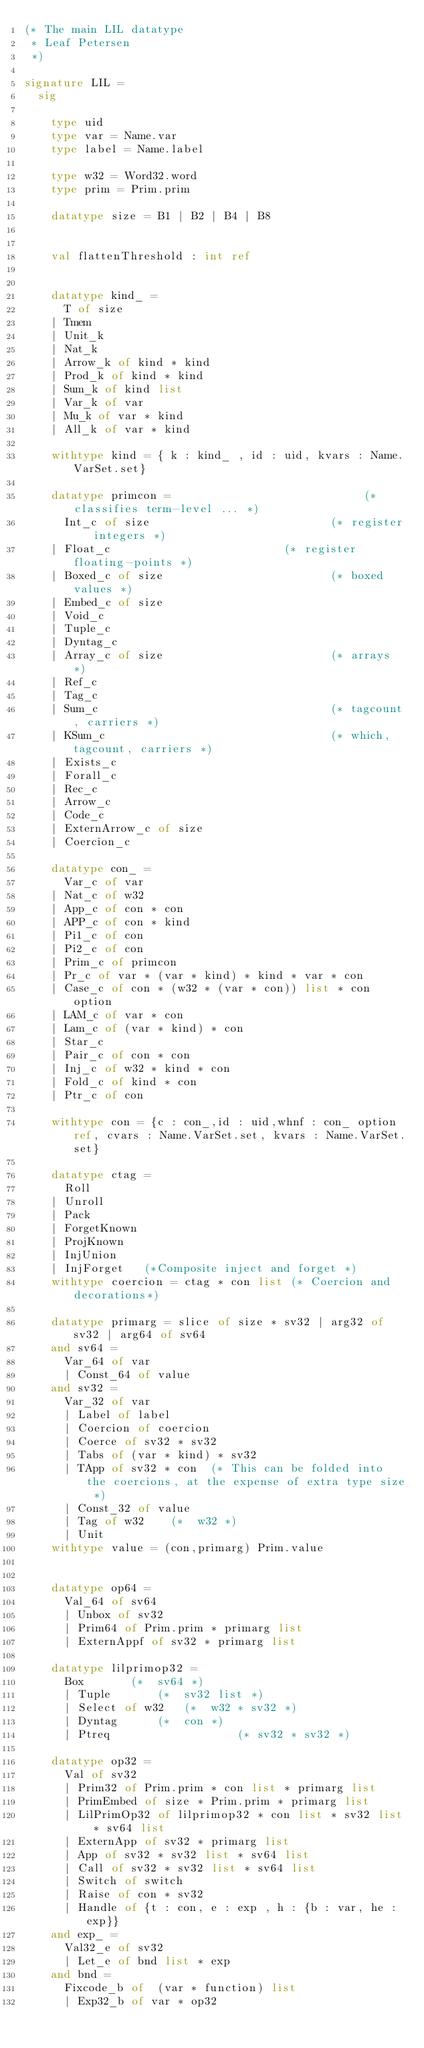Convert code to text. <code><loc_0><loc_0><loc_500><loc_500><_SML_>(* The main LIL datatype
 * Leaf Petersen
 *)

signature LIL =
  sig

    type uid    
    type var = Name.var
    type label = Name.label
      
    type w32 = Word32.word
    type prim = Prim.prim

    datatype size = B1 | B2 | B4 | B8


    val flattenThreshold : int ref


    datatype kind_ =
      T of size
    | Tmem
    | Unit_k
    | Nat_k
    | Arrow_k of kind * kind
    | Prod_k of kind * kind
    | Sum_k of kind list
    | Var_k of var
    | Mu_k of var * kind
    | All_k of var * kind

    withtype kind = { k : kind_ , id : uid, kvars : Name.VarSet.set}
      
    datatype primcon =                             (* classifies term-level ... *)
      Int_c of size                           (* register integers *)
    | Float_c                          (* register floating-points *)
    | Boxed_c of size                         (* boxed values *)
    | Embed_c of size
    | Void_c
    | Tuple_c
    | Dyntag_c
    | Array_c of size                         (* arrays *)
    | Ref_c
    | Tag_c
    | Sum_c                                   (* tagcount, carriers *)
    | KSum_c                                  (* which, tagcount, carriers *)
    | Exists_c
    | Forall_c
    | Rec_c
    | Arrow_c
    | Code_c 
    | ExternArrow_c of size
    | Coercion_c

    datatype con_ = 
      Var_c of var
    | Nat_c of w32
    | App_c of con * con
    | APP_c of con * kind
    | Pi1_c of con
    | Pi2_c of con
    | Prim_c of primcon
    | Pr_c of var * (var * kind) * kind * var * con
    | Case_c of con * (w32 * (var * con)) list * con option  
    | LAM_c of var * con
    | Lam_c of (var * kind) * con
    | Star_c
    | Pair_c of con * con
    | Inj_c of w32 * kind * con 
    | Fold_c of kind * con
    | Ptr_c of con

    withtype con = {c : con_,id : uid,whnf : con_ option ref, cvars : Name.VarSet.set, kvars : Name.VarSet.set} 

    datatype ctag = 
      Roll 
    | Unroll 
    | Pack 
    | ForgetKnown 
    | ProjKnown
    | InjUnion
    | InjForget   (*Composite inject and forget *)
    withtype coercion = ctag * con list (* Coercion and decorations*)

    datatype primarg = slice of size * sv32 | arg32 of sv32 | arg64 of sv64
    and sv64 = 
      Var_64 of var 
      | Const_64 of value
    and sv32 = 
      Var_32 of var 
      | Label of label
      | Coercion of coercion 
      | Coerce of sv32 * sv32 
      | Tabs of (var * kind) * sv32
      | TApp of sv32 * con  (* This can be folded into the coercions, at the expense of extra type size *)
      | Const_32 of value
      | Tag of w32		(*  w32 *)
      | Unit
    withtype value = (con,primarg) Prim.value


    datatype op64 = 
      Val_64 of sv64 
      | Unbox of sv32
      | Prim64 of Prim.prim * primarg list
      | ExternAppf of sv32 * primarg list

    datatype lilprimop32 = 
      Box 			(*  sv64 *)
      | Tuple 			(*  sv32 list *)
      | Select of w32		(*  w32 * sv32 *)
      | Dyntag 			(*  con *)
      | Ptreq                   (* sv32 * sv32 *)

    datatype op32 = 
      Val of sv32 
      | Prim32 of Prim.prim * con list * primarg list
      | PrimEmbed of size * Prim.prim * primarg list
      | LilPrimOp32 of lilprimop32 * con list * sv32 list * sv64 list
      | ExternApp of sv32 * primarg list 
      | App of sv32 * sv32 list * sv64 list
      | Call of sv32 * sv32 list * sv64 list
      | Switch of switch
      | Raise of con * sv32 
      | Handle of {t : con, e : exp , h : {b : var, he : exp}}
    and exp_ = 
      Val32_e of sv32
      | Let_e of bnd list * exp
    and bnd =
      Fixcode_b of  (var * function) list
      | Exp32_b of var * op32</code> 